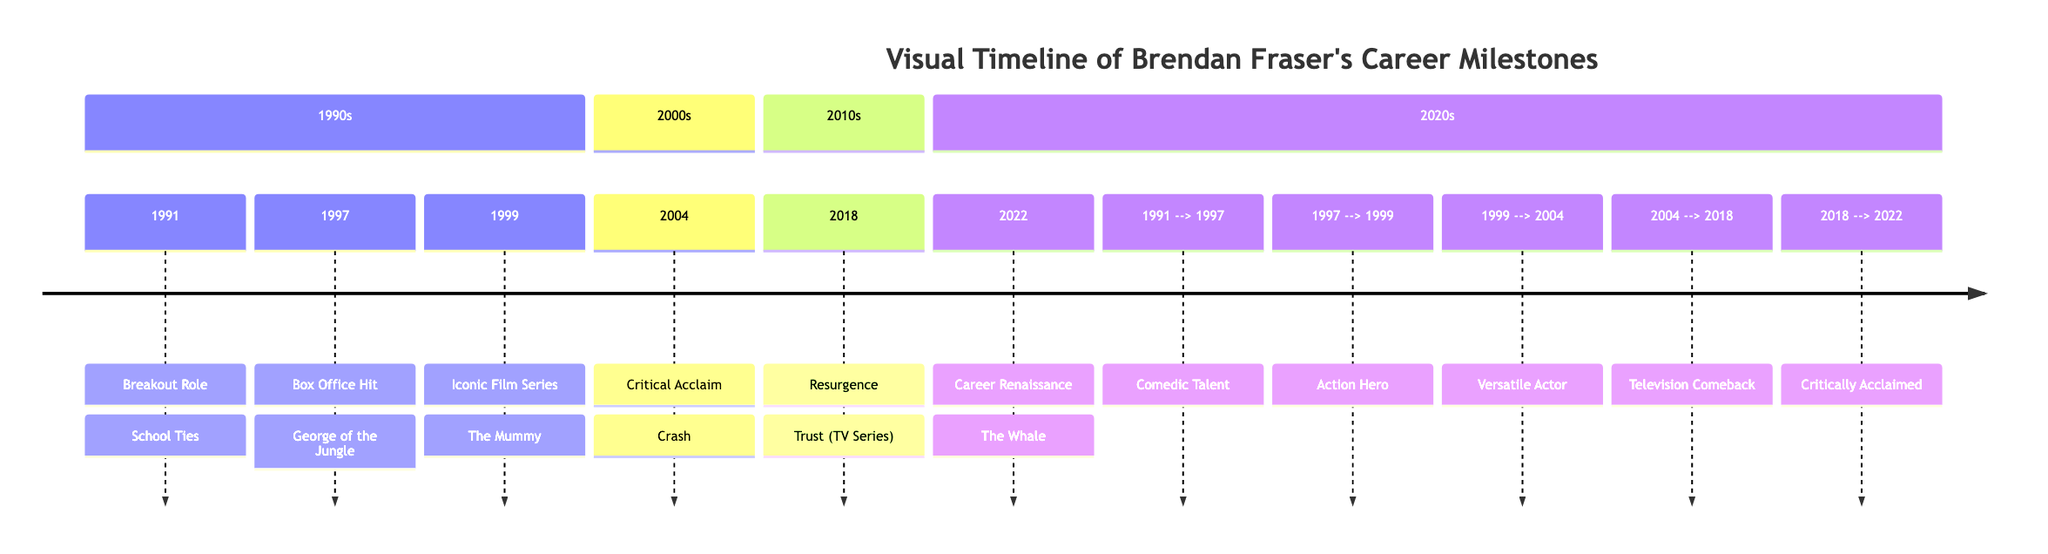What was Brendan Fraser's breakout role? The diagram indicates that Brendan Fraser's breakout role was in 1991, specifically in the film "School Ties."
Answer: School Ties Which film released in 1999 is listed as part of an iconic film series? According to the timeline, the iconic film series released in 1999 is "The Mummy."
Answer: The Mummy How many decades are represented in Brendan Fraser's career timeline? The timeline is divided into four sections labeled with decades: 1990s, 2000s, 2010s, and 2020s, making a total of four decades.
Answer: 4 What is the nature of Brendan Fraser's career event in 2004? In 2004, Brendan Fraser received critical acclaim for his role in "Crash," indicating a significant recognition of his acting achievements.
Answer: Critical Acclaim What career milestone transition is indicated between the years 2004 and 2018? The diagram shows a transition labeled "Television Comeback" between the years 2004 and 2018, indicating a shift in his career focus to television during this period.
Answer: Television Comeback Which film marks Brendan Fraser's career renaissance, and in what year did it occur? The diagram clearly states that Brendan Fraser's career renaissance occurred in 2022 with the film "The Whale."
Answer: The Whale What milestone links the years 1997 and 1999 in Brendan Fraser's career? The timeline indicates a connection marked "Action Hero" between the years 1997 and 1999, highlighting his progressing career in action roles during that time.
Answer: Action Hero What describing term is associated with Brendan Fraser's role in the 2018 TV series "Trust"? The diagram labels the 2018 TV series "Trust" as a "Resurgence," indicating a comeback in Fraser's acting career.
Answer: Resurgence Which milestone signifies Brendan Fraser's versatility, and in what year is it indicated? The diagram points out that Brendan Fraser is described as a "Versatile Actor" during the transition from 1999 to 2004, covering that specific timeframe.
Answer: Versatile Actor 